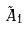<formula> <loc_0><loc_0><loc_500><loc_500>\tilde { A } _ { 1 }</formula> 